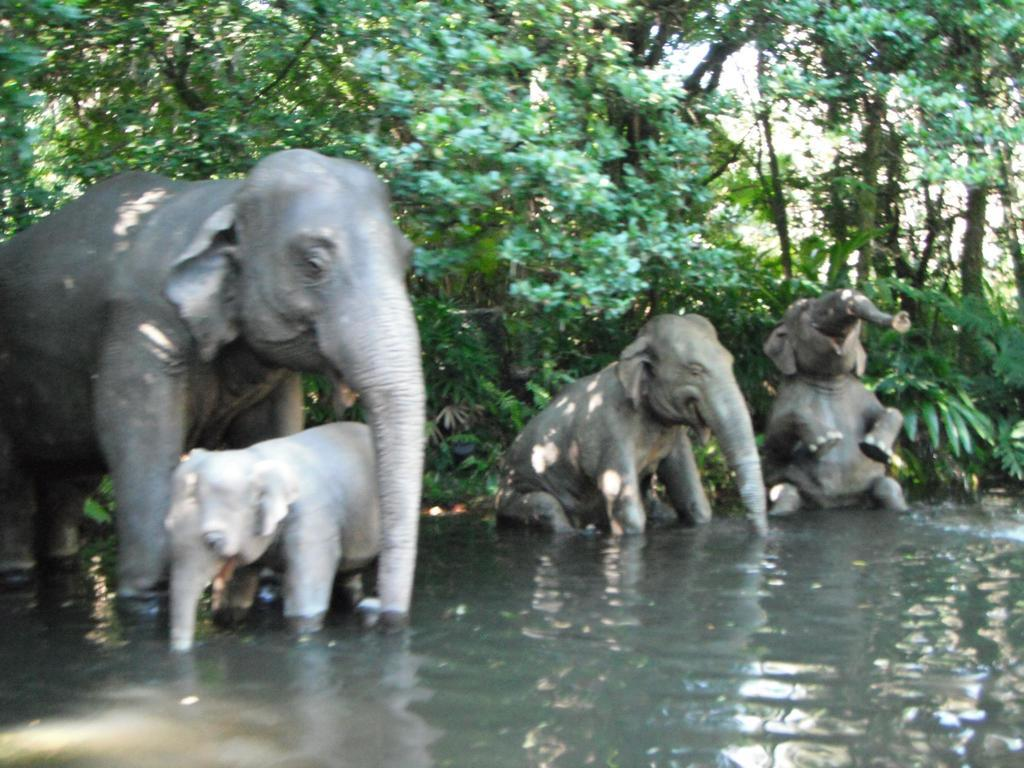What animals are present in the image? There are elephants in the image. Where are the elephants located in the image? The elephants are in a pond. What can be seen in the background of the image? There are trees visible in the background of the image. What type of pan can be seen being used by the elephants in the image? There is no pan present in the image, and the elephants are not using any pan. Can you tell me how many coasts are visible in the image? There are no coasts visible in the image; it features elephants in a pond with trees in the background. 